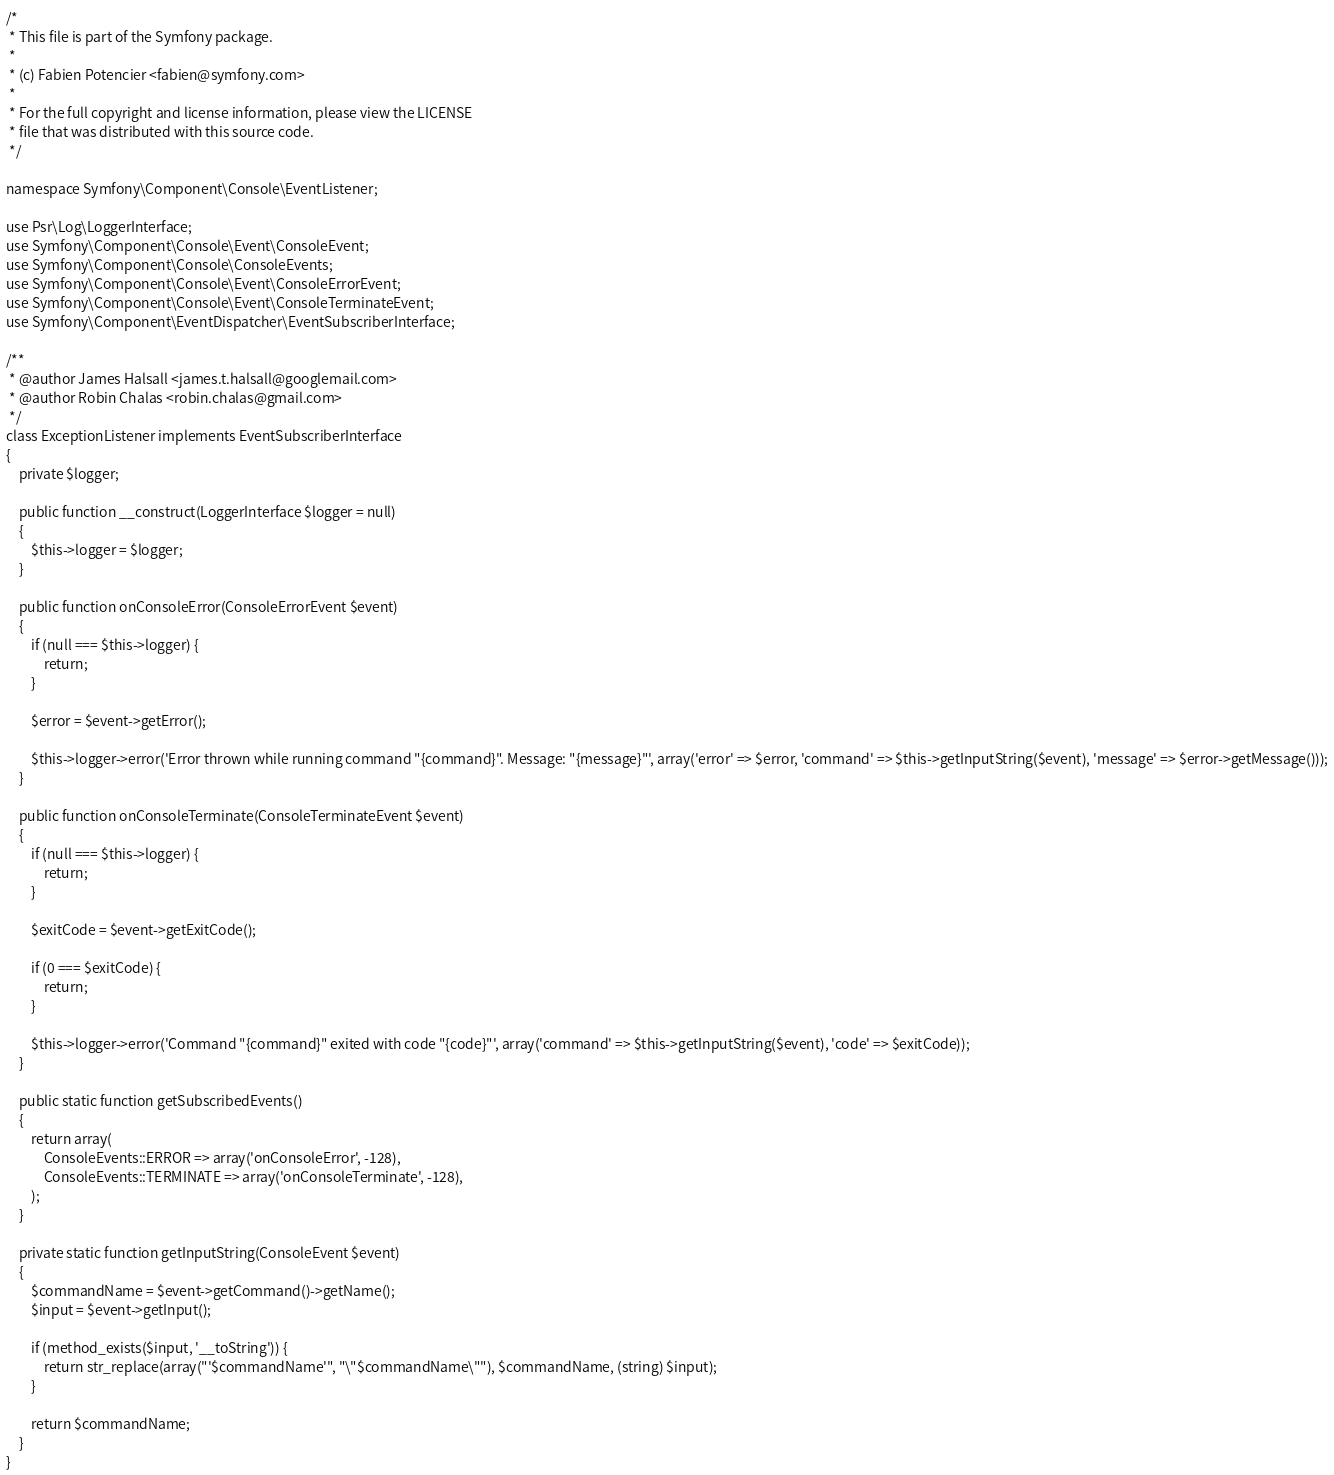Convert code to text. <code><loc_0><loc_0><loc_500><loc_500><_PHP_>
/*
 * This file is part of the Symfony package.
 *
 * (c) Fabien Potencier <fabien@symfony.com>
 *
 * For the full copyright and license information, please view the LICENSE
 * file that was distributed with this source code.
 */

namespace Symfony\Component\Console\EventListener;

use Psr\Log\LoggerInterface;
use Symfony\Component\Console\Event\ConsoleEvent;
use Symfony\Component\Console\ConsoleEvents;
use Symfony\Component\Console\Event\ConsoleErrorEvent;
use Symfony\Component\Console\Event\ConsoleTerminateEvent;
use Symfony\Component\EventDispatcher\EventSubscriberInterface;

/**
 * @author James Halsall <james.t.halsall@googlemail.com>
 * @author Robin Chalas <robin.chalas@gmail.com>
 */
class ExceptionListener implements EventSubscriberInterface
{
    private $logger;

    public function __construct(LoggerInterface $logger = null)
    {
        $this->logger = $logger;
    }

    public function onConsoleError(ConsoleErrorEvent $event)
    {
        if (null === $this->logger) {
            return;
        }

        $error = $event->getError();

        $this->logger->error('Error thrown while running command "{command}". Message: "{message}"', array('error' => $error, 'command' => $this->getInputString($event), 'message' => $error->getMessage()));
    }

    public function onConsoleTerminate(ConsoleTerminateEvent $event)
    {
        if (null === $this->logger) {
            return;
        }

        $exitCode = $event->getExitCode();

        if (0 === $exitCode) {
            return;
        }

        $this->logger->error('Command "{command}" exited with code "{code}"', array('command' => $this->getInputString($event), 'code' => $exitCode));
    }

    public static function getSubscribedEvents()
    {
        return array(
            ConsoleEvents::ERROR => array('onConsoleError', -128),
            ConsoleEvents::TERMINATE => array('onConsoleTerminate', -128),
        );
    }

    private static function getInputString(ConsoleEvent $event)
    {
        $commandName = $event->getCommand()->getName();
        $input = $event->getInput();

        if (method_exists($input, '__toString')) {
            return str_replace(array("'$commandName'", "\"$commandName\""), $commandName, (string) $input);
        }

        return $commandName;
    }
}
</code> 